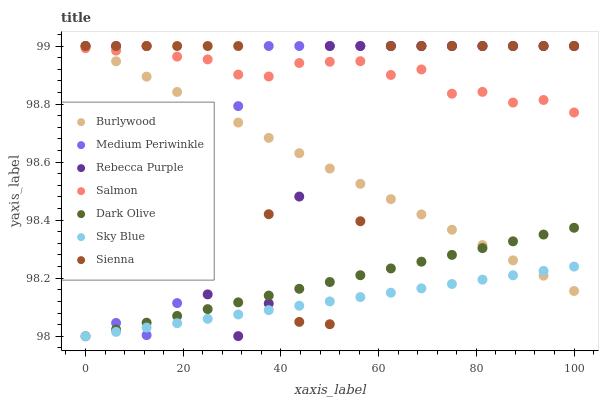Does Sky Blue have the minimum area under the curve?
Answer yes or no. Yes. Does Salmon have the maximum area under the curve?
Answer yes or no. Yes. Does Medium Periwinkle have the minimum area under the curve?
Answer yes or no. No. Does Medium Periwinkle have the maximum area under the curve?
Answer yes or no. No. Is Dark Olive the smoothest?
Answer yes or no. Yes. Is Sienna the roughest?
Answer yes or no. Yes. Is Medium Periwinkle the smoothest?
Answer yes or no. No. Is Medium Periwinkle the roughest?
Answer yes or no. No. Does Dark Olive have the lowest value?
Answer yes or no. Yes. Does Medium Periwinkle have the lowest value?
Answer yes or no. No. Does Rebecca Purple have the highest value?
Answer yes or no. Yes. Does Dark Olive have the highest value?
Answer yes or no. No. Is Sky Blue less than Salmon?
Answer yes or no. Yes. Is Salmon greater than Sky Blue?
Answer yes or no. Yes. Does Sky Blue intersect Dark Olive?
Answer yes or no. Yes. Is Sky Blue less than Dark Olive?
Answer yes or no. No. Is Sky Blue greater than Dark Olive?
Answer yes or no. No. Does Sky Blue intersect Salmon?
Answer yes or no. No. 